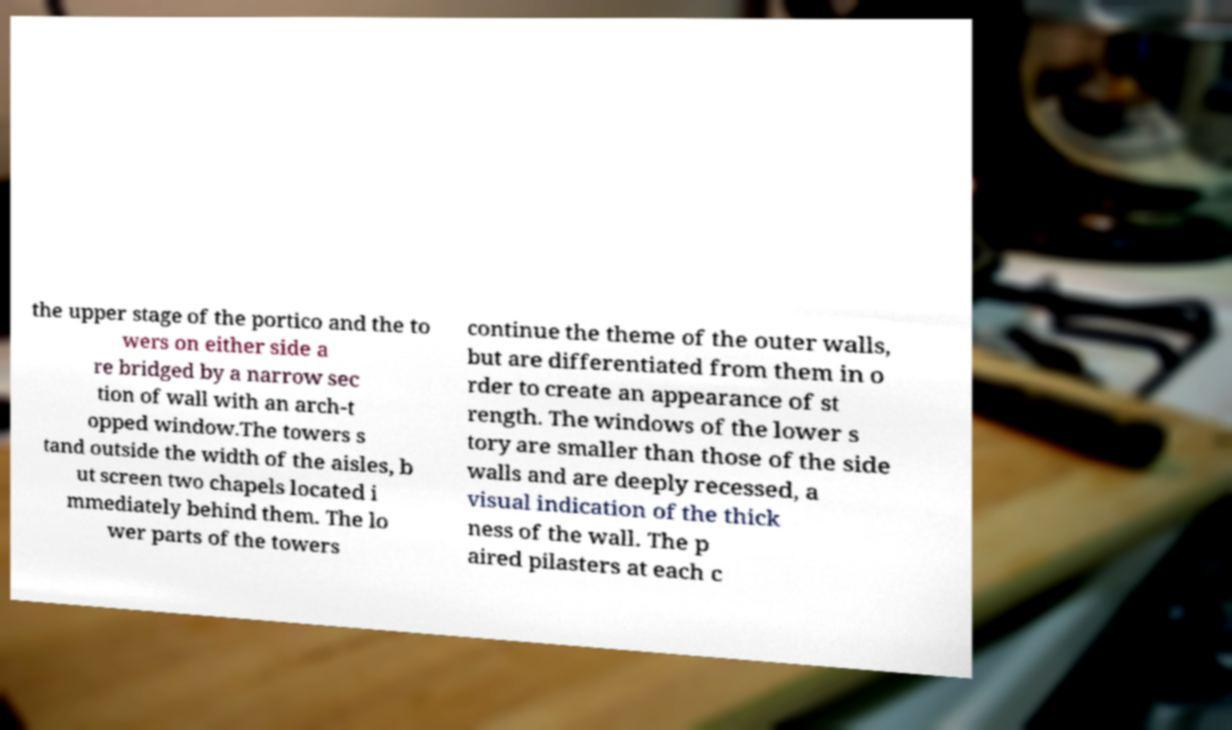Could you assist in decoding the text presented in this image and type it out clearly? the upper stage of the portico and the to wers on either side a re bridged by a narrow sec tion of wall with an arch-t opped window.The towers s tand outside the width of the aisles, b ut screen two chapels located i mmediately behind them. The lo wer parts of the towers continue the theme of the outer walls, but are differentiated from them in o rder to create an appearance of st rength. The windows of the lower s tory are smaller than those of the side walls and are deeply recessed, a visual indication of the thick ness of the wall. The p aired pilasters at each c 